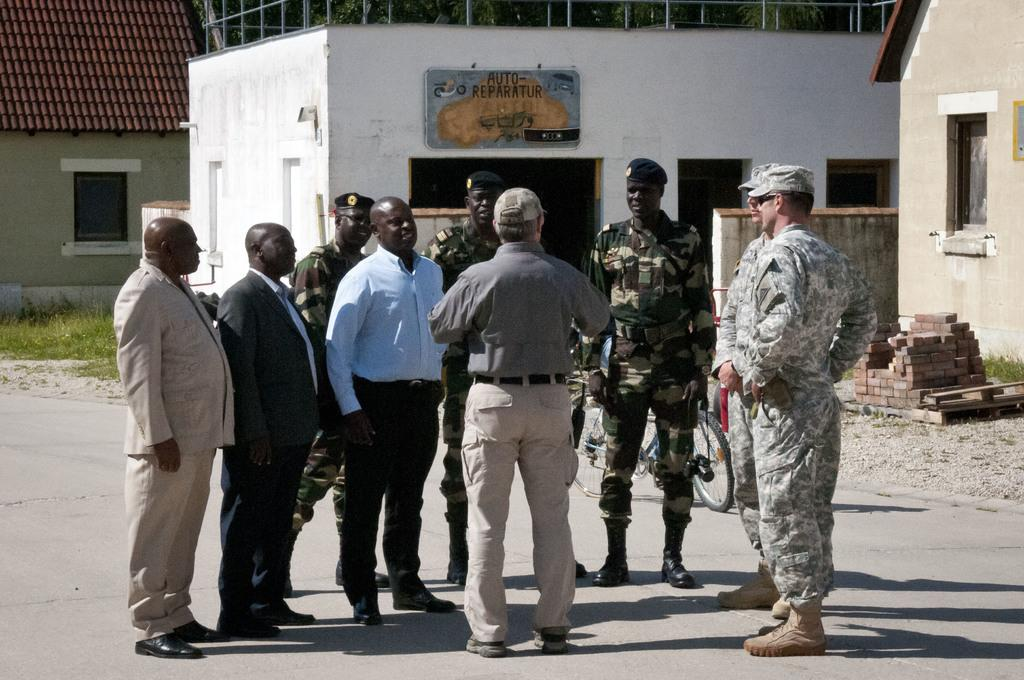What are the main subjects in the middle of the image? There are people standing in the middle of the image. What object can be seen behind the people? There is a bicycle visible behind the people. What type of structures can be seen in the background of the image? There are houses in the background of the image. What material is present in the background of the image? Bricks are present in the background of the image. What type of songs can be heard being sung by the people in the image? There is no indication in the image that the people are singing songs, so it cannot be determined from the picture. 